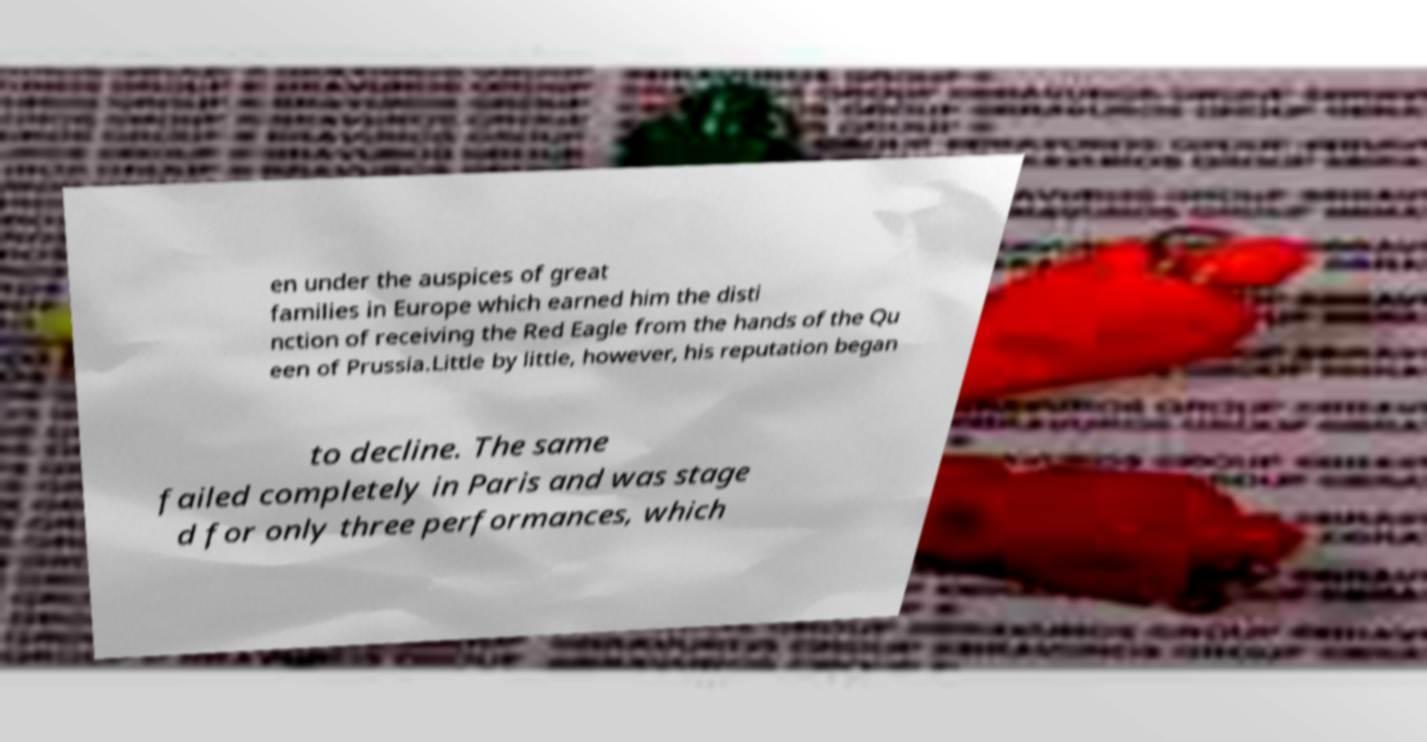What messages or text are displayed in this image? I need them in a readable, typed format. en under the auspices of great families in Europe which earned him the disti nction of receiving the Red Eagle from the hands of the Qu een of Prussia.Little by little, however, his reputation began to decline. The same failed completely in Paris and was stage d for only three performances, which 